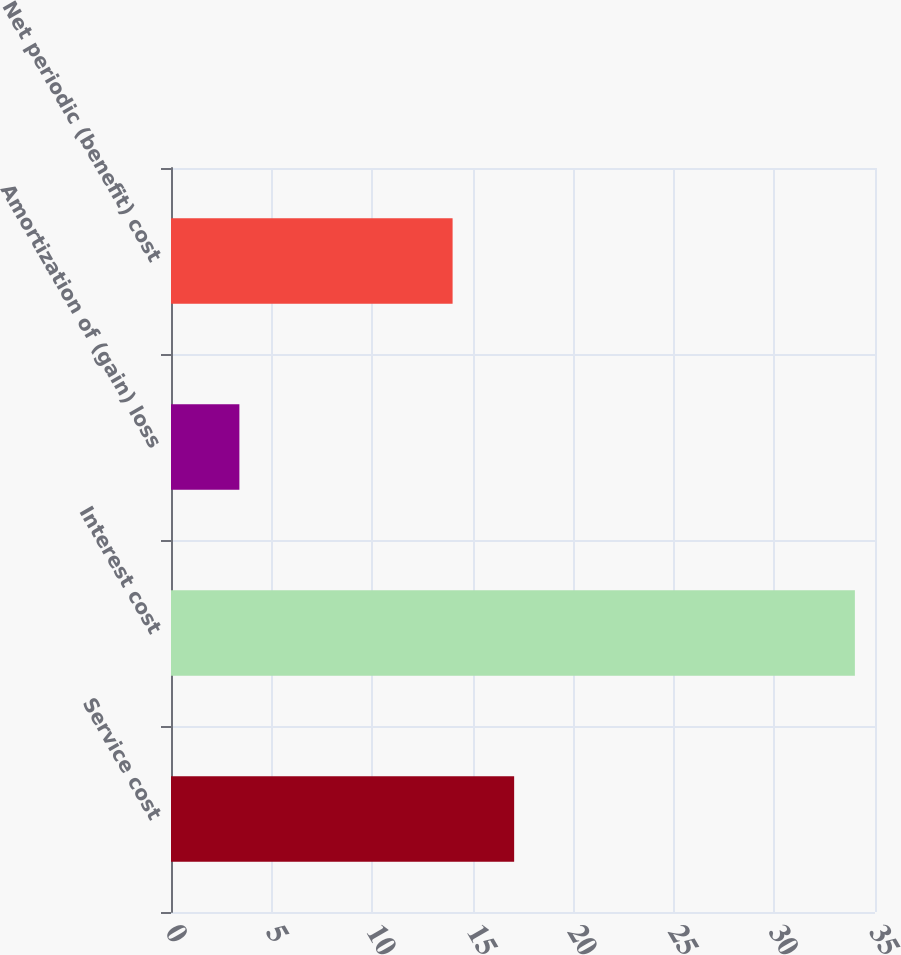Convert chart to OTSL. <chart><loc_0><loc_0><loc_500><loc_500><bar_chart><fcel>Service cost<fcel>Interest cost<fcel>Amortization of (gain) loss<fcel>Net periodic (benefit) cost<nl><fcel>17.06<fcel>34<fcel>3.4<fcel>14<nl></chart> 